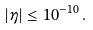Convert formula to latex. <formula><loc_0><loc_0><loc_500><loc_500>| \eta | \leq 1 0 ^ { - 1 0 } \, .</formula> 